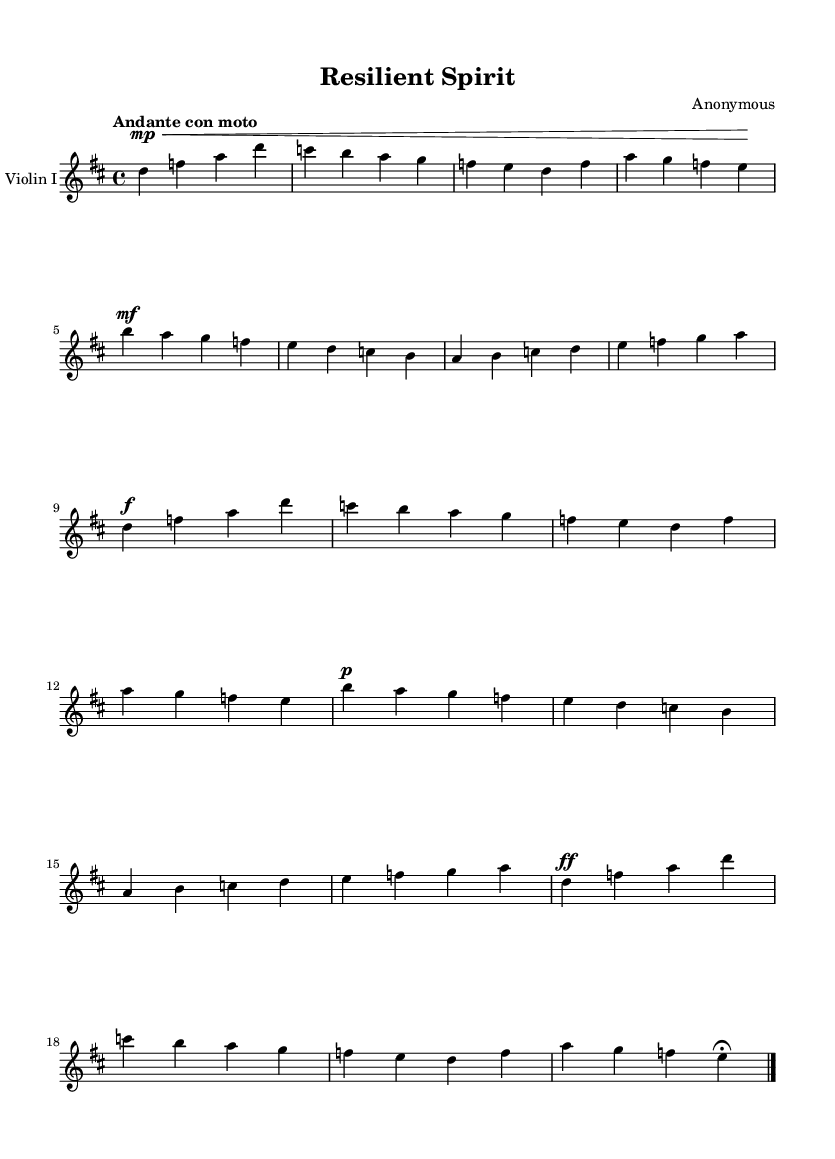What is the key signature of this music? The key signature is indicated at the beginning of the score, showing two sharps. This corresponds to the D major scale.
Answer: D major What is the time signature of the piece? The time signature is located at the beginning of the score, displayed as 4/4. This indicates that there are four beats per measure and a quarter note receives one beat.
Answer: 4/4 What tempo marking is given for this composition? The tempo marking appears at the beginning of the score, stating "Andante con moto," which indicates a moderate walking pace with a slight increase in speed.
Answer: Andante con moto How many measures are in the provided section of music? By counting the vertical lines, known as bar lines, in the score, we find there are a total of eight measures present in the excerpt.
Answer: 8 What is the dynamic marking for the first phrase? The first dynamic marking can be found associated with the first measure where it indicates "mp," meaning mezzo-piano, which signifies a moderately soft volume.
Answer: mezzo-piano What is the final dynamic marking of the passage? The last dynamic marking appears at the end of the last measure of the piece, showing "ff," which stands for fortissimo, indicating a very loud volume.
Answer: fortissimo What is the melodic range found in the violin part? To determine the melodic range, we look at the highest and lowest notes in the provided music. The lowest note is D (below the staff) and the highest note is B (above the staff), indicating a range spanning over an octave.
Answer: Over an octave 